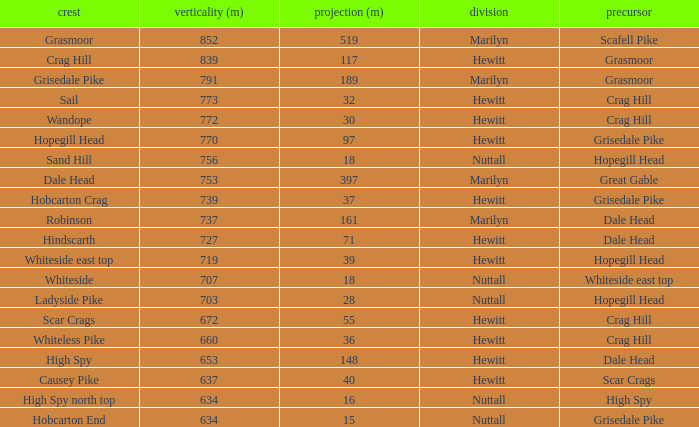What is the lowest height for Parent grasmoor when it has a Prom larger than 117? 791.0. 